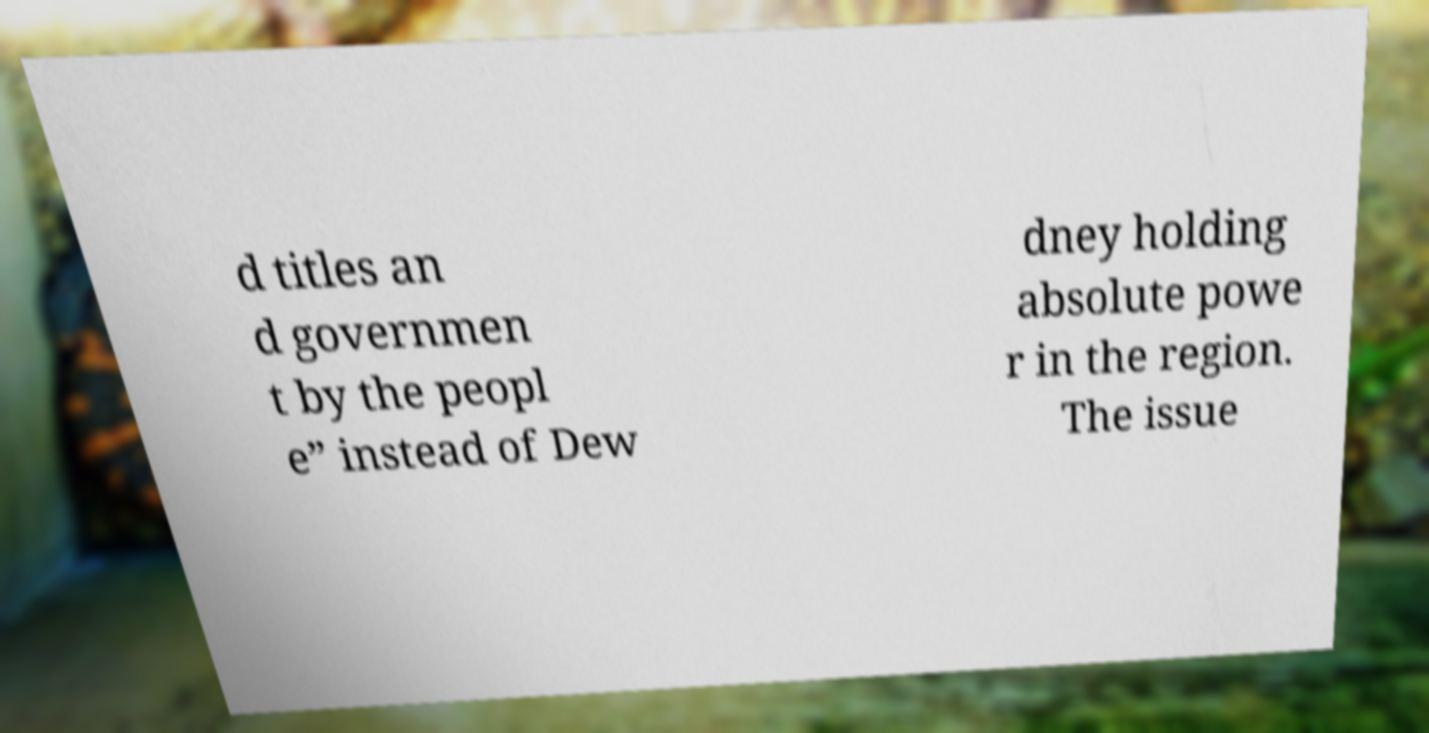There's text embedded in this image that I need extracted. Can you transcribe it verbatim? d titles an d governmen t by the peopl e” instead of Dew dney holding absolute powe r in the region. The issue 